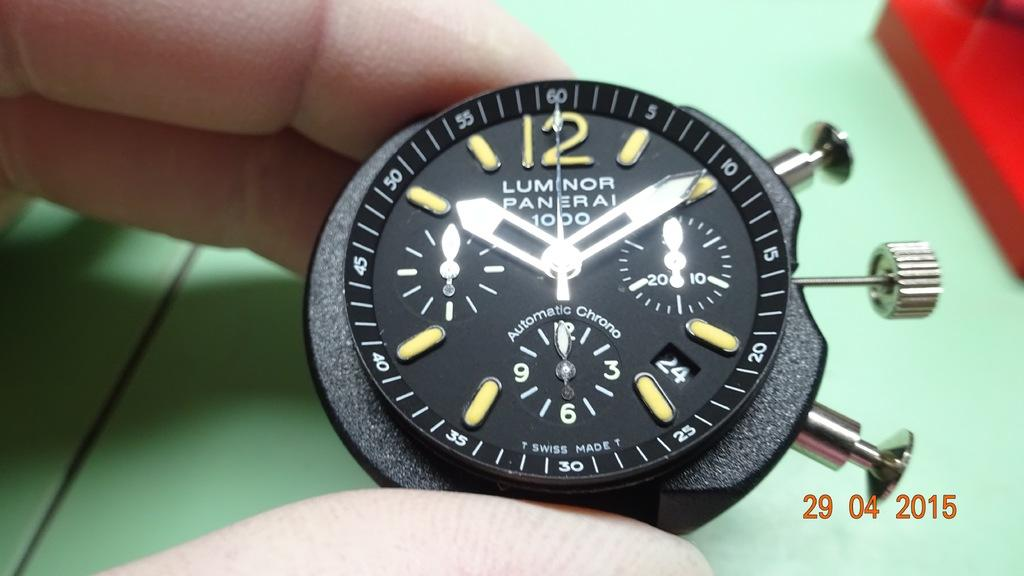<image>
Render a clear and concise summary of the photo. A Lumnor Panerai brand watch is on display. 